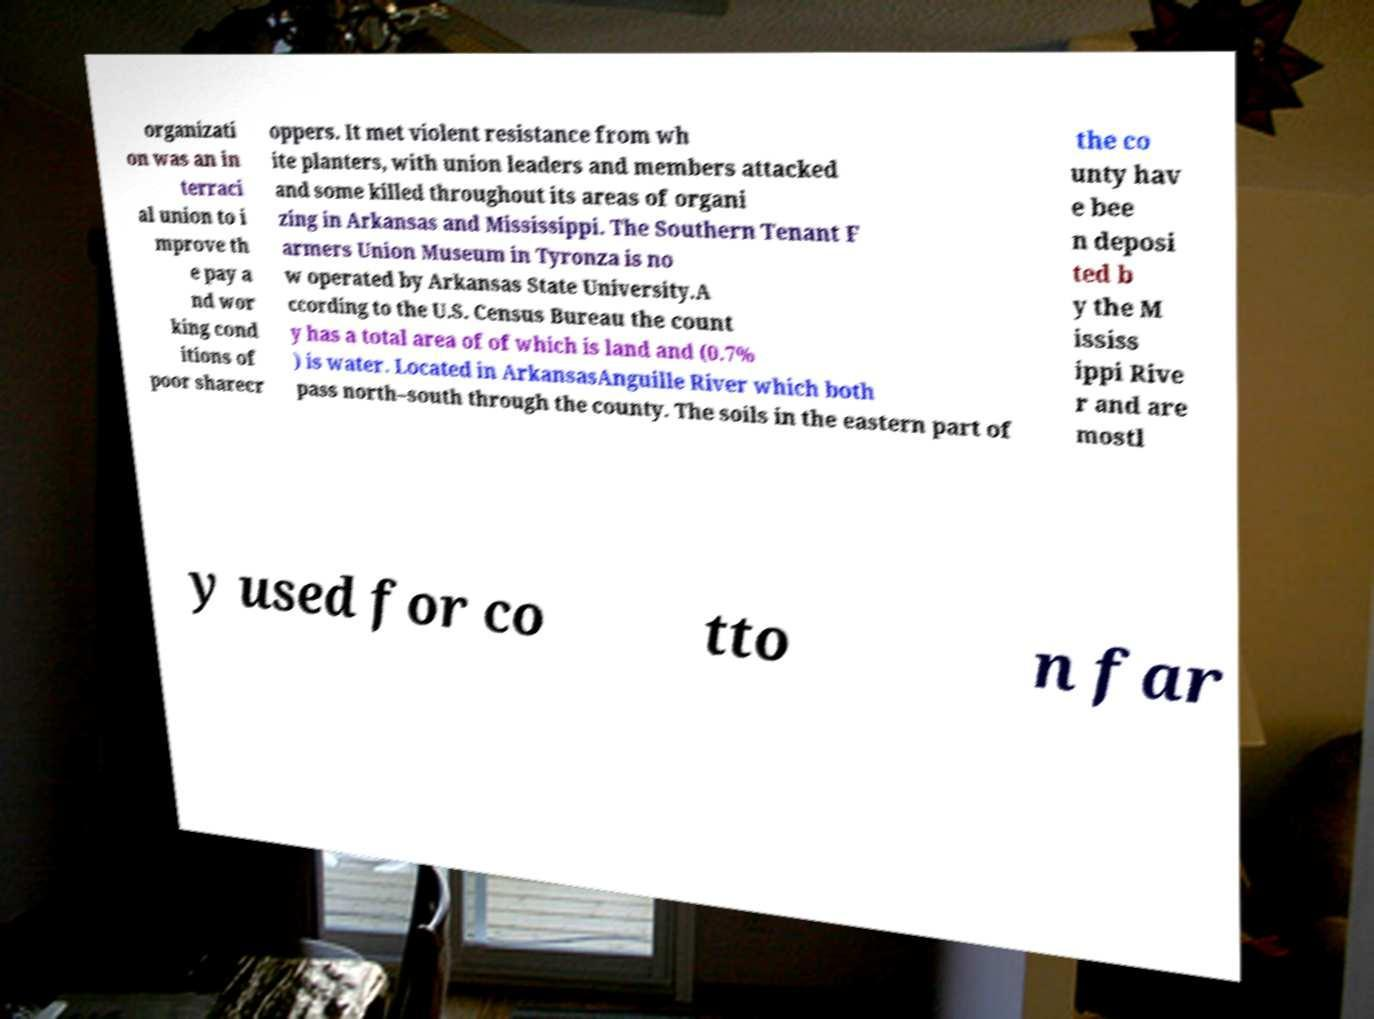I need the written content from this picture converted into text. Can you do that? organizati on was an in terraci al union to i mprove th e pay a nd wor king cond itions of poor sharecr oppers. It met violent resistance from wh ite planters, with union leaders and members attacked and some killed throughout its areas of organi zing in Arkansas and Mississippi. The Southern Tenant F armers Union Museum in Tyronza is no w operated by Arkansas State University.A ccording to the U.S. Census Bureau the count y has a total area of of which is land and (0.7% ) is water. Located in ArkansasAnguille River which both pass north–south through the county. The soils in the eastern part of the co unty hav e bee n deposi ted b y the M ississ ippi Rive r and are mostl y used for co tto n far 